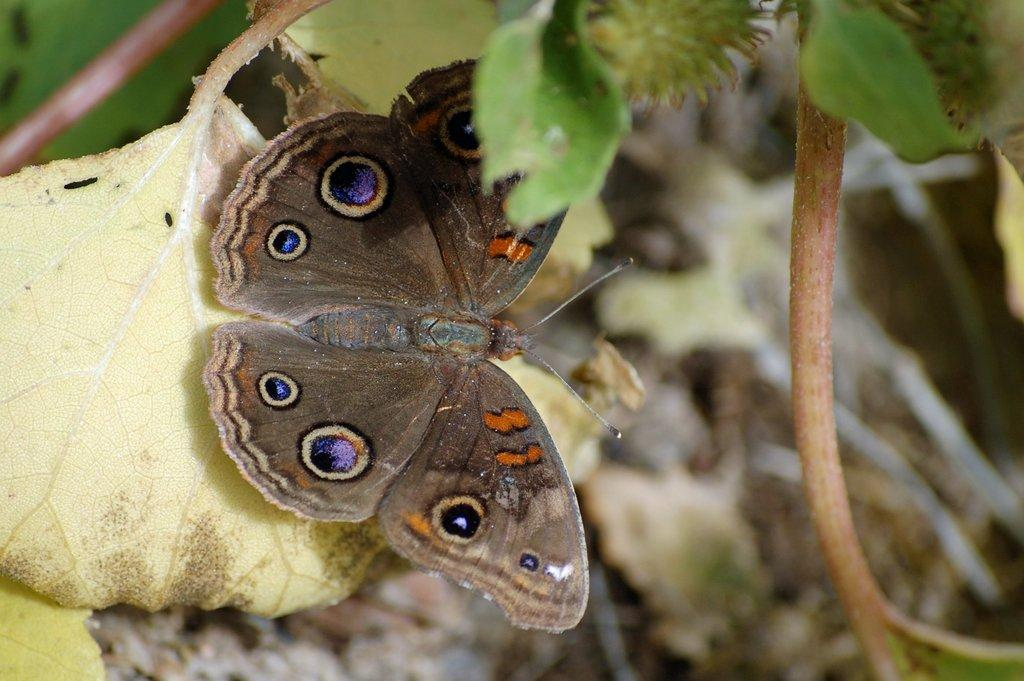What is the main subject of the image? There is a butterfly in the image. Where is the butterfly located? The butterfly is on a leaf. Can you describe the background of the image? The background of the image is blurred. What month is the butterfly laying its eggs in the image? There is no mention of eggs or a specific month in the image, so we cannot determine when the butterfly might be laying eggs. 